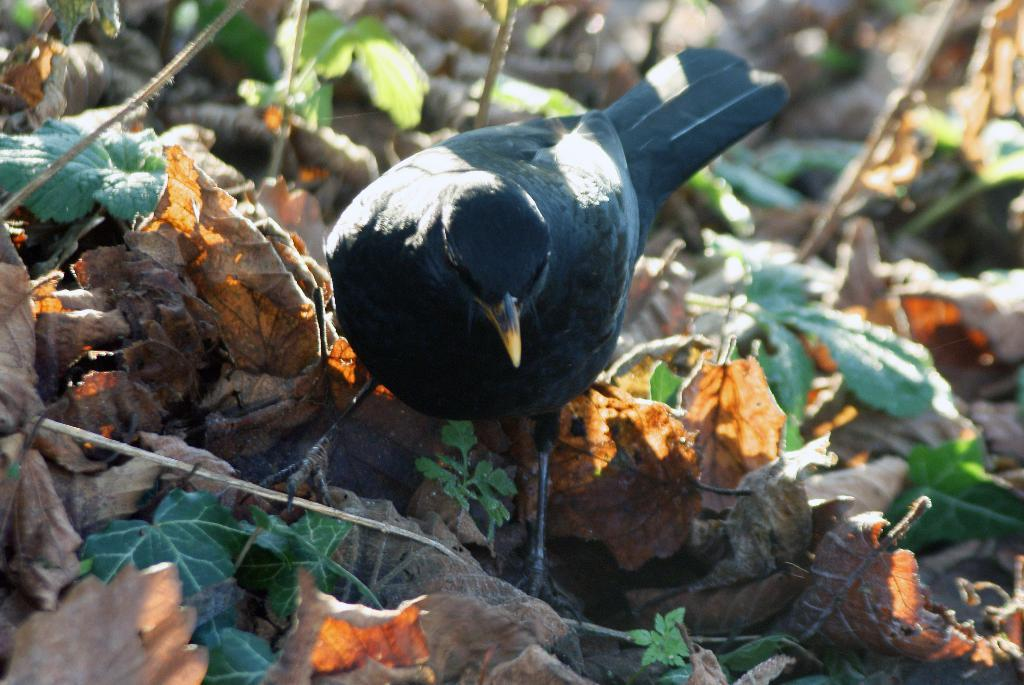What type of living organisms can be seen in the image? Plants can be seen in the image. What is on the ground in the image? There are leaves on the ground in the image. What animal is present in the image? There is a bird on the leaves in the image. What type of drink is the bird holding in the image? There is no drink present in the image; the bird is on the leaves. 